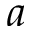<formula> <loc_0><loc_0><loc_500><loc_500>a</formula> 